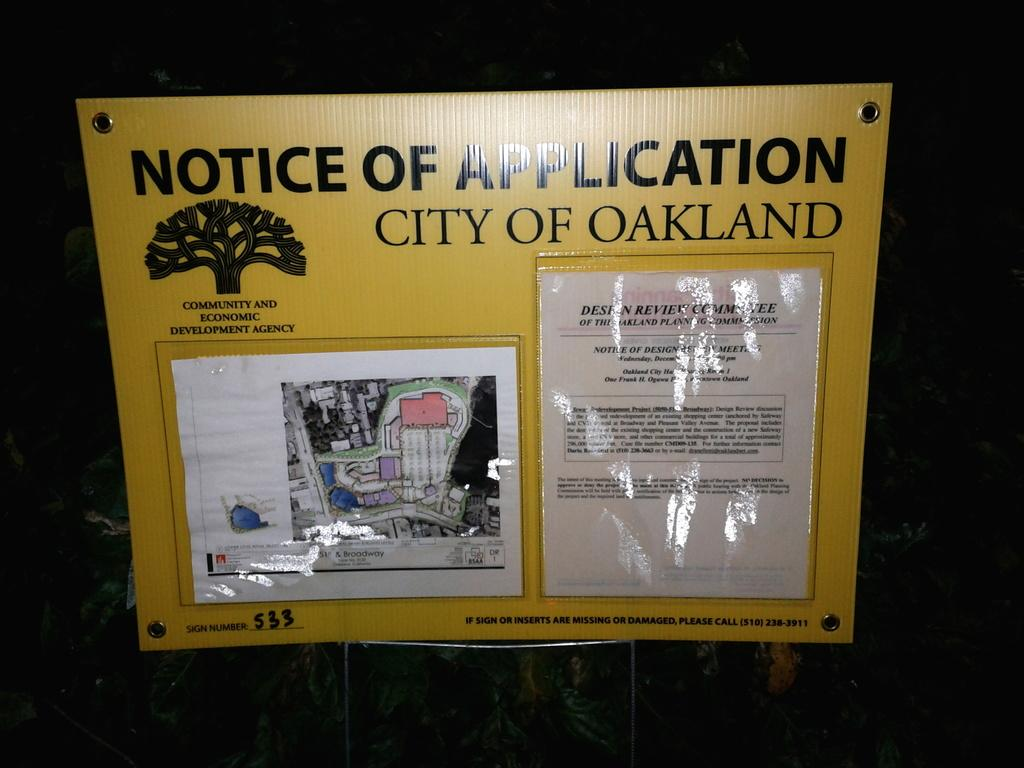Provide a one-sentence caption for the provided image. A yellow sign displayed that says, Notice of Application City of Oakland at the top. 